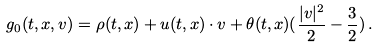Convert formula to latex. <formula><loc_0><loc_0><loc_500><loc_500>g _ { 0 } ( t , x , v ) = \rho ( t , x ) + u ( t , x ) \cdot v + \theta ( t , x ) ( \frac { | v | ^ { 2 } } { 2 } - \frac { 3 } { 2 } ) \, .</formula> 